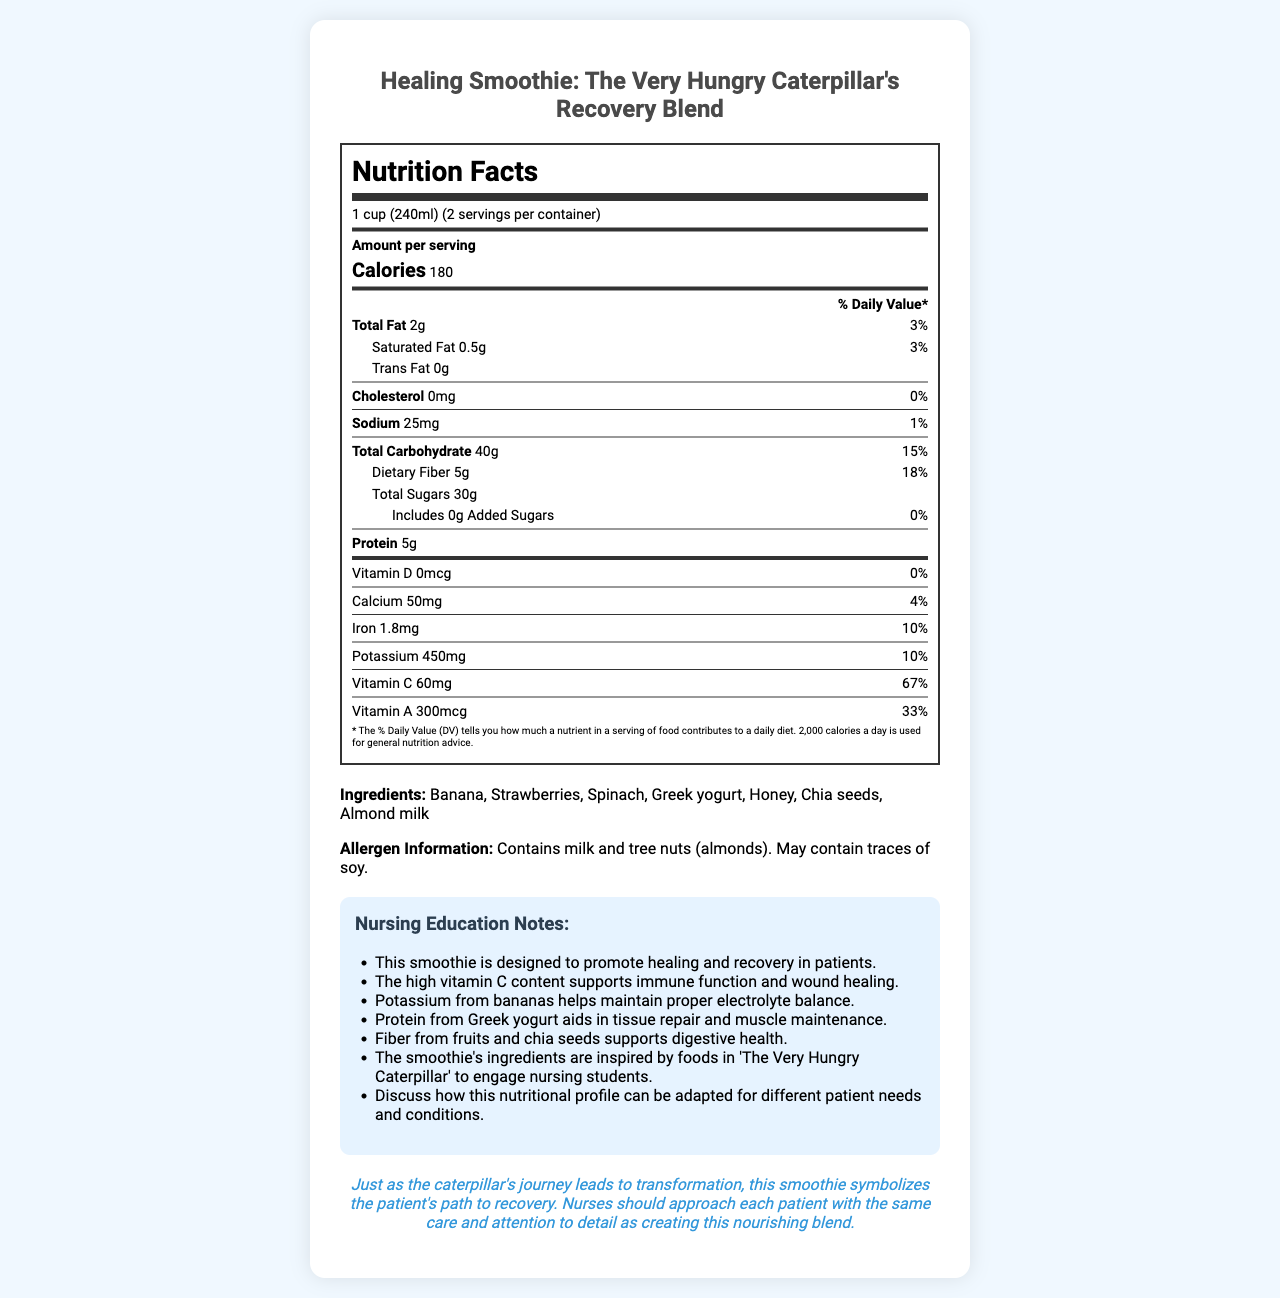what is the serving size? The serving size is clearly mentioned at the top of the nutrition facts label as "1 cup (240ml)".
Answer: 1 cup (240ml) how many servings are there per container? The servings per container are given right after the serving size on the label, stating there are 2 servings per container.
Answer: 2 how much protein does each serving contain? The amount of protein per serving is listed under the "Amount per serving" section, where it mentions "Protein" as 5g.
Answer: 5g how much dietary fiber is in each serving? Under the total carbohydrate section, "Dietary Fiber" is listed as 5g.
Answer: 5g what is the percentage of the daily value for vitamin C per serving? The daily value for Vitamin C per serving is shown as 67% in the micronutrient section of the nutrition label.
Answer: 67% which ingredient is not listed in the smoothie? A. Banana B. Apples C. Strawberries The ingredients list under the main section does not include Apples, but it lists Banana and Strawberries.
Answer: B which one of the following nutrients does the smoothie provide 10% of the daily value for? A. Calcium B. Iron C. Sodium D. Protein Under the micronutrient section, Iron is listed as providing 10% of the daily value per serving.
Answer: B does the product contain any added sugars? The label specifies "Includes 0g Added Sugars" under the total sugars section.
Answer: No is this product free from allergens? The allergen information section specifies that the product contains milk and tree nuts (almonds) and may contain traces of soy.
Answer: No summarize the main components of this document. The document gives detailed nutritional information for a smoothie designed to aid healing, lists its ingredients and allergens, includes educational notes for nursing students, and provides an empathy lesson to emphasize patient care.
Answer: This document provides nutrition facts for "Healing Smoothie: The Very Hungry Caterpillar's Recovery Blend". It includes serving size and number, macronutrient and micronutrient values per serving, an ingredients list, allergen information, nursing education notes, and an empathy lesson. The smoothie aims to aid recovery with beneficial nutrients inspired by children's book characters. what is the total calorie content per container? With 180 calories per serving and 2 servings per container, the total calorie content per container is 180 * 2 = 360 calories.
Answer: 360 calories how does the smoothie contribute to digestive health? The nursing education notes mention that fiber from fruits and chia seeds in the smoothie supports digestive health.
Answer: Fiber from fruits and chia seeds what is the source of protein in the smoothie? According to the ingredients listed, Greek yogurt is the source of protein in the smoothie.
Answer: Greek yogurt how much potassium is provided by each serving in mg? The nutrient section lists potassium as providing 450mg per serving.
Answer: 450mg how long will it take for results to appear after consuming the smoothie? The document provides nutritional details and educational notes but does not specify the time frame for seeing results after consuming the smoothie.
Answer: Not enough information what lesson does the empathy section convey for nursing students? The empathy lesson emphasizes that nurses should care for each patient with the same detail and care given to creating the nourishing smoothie, symbolizing the patient's path to recovery.
Answer: Approach each patient with care and attention 